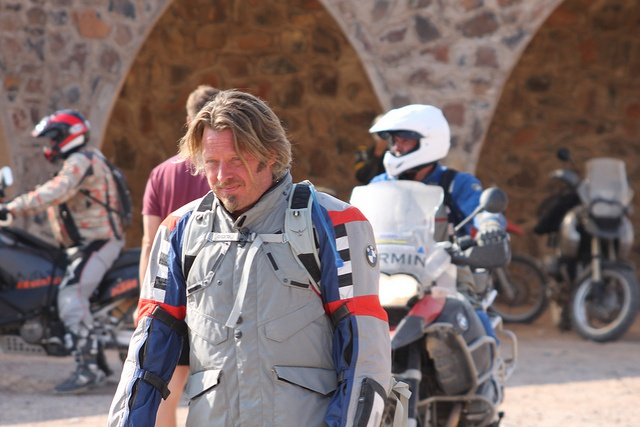Describe the objects in this image and their specific colors. I can see people in gray, darkgray, lightgray, and black tones, motorcycle in gray, lightgray, darkgray, and black tones, motorcycle in gray and black tones, people in gray, darkgray, and black tones, and motorcycle in gray, black, and darkgray tones in this image. 